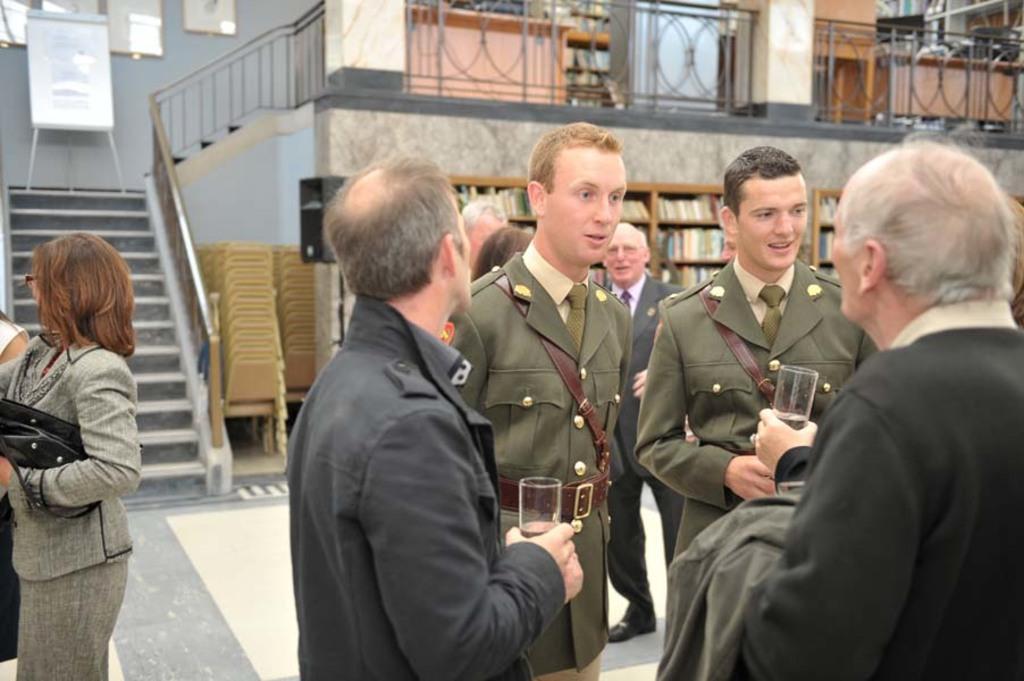Please provide a concise description of this image. In this picture there are two persons standing and holding the glasses and there are two persons with similar dress are standing. At the back there are group of people and there are books in the cupboard. On the left side of the image there are chairs and there is a staircase and there are frames on the wall and there is a board on the stand. At the top there is a railing and behind the railing there is a table. 